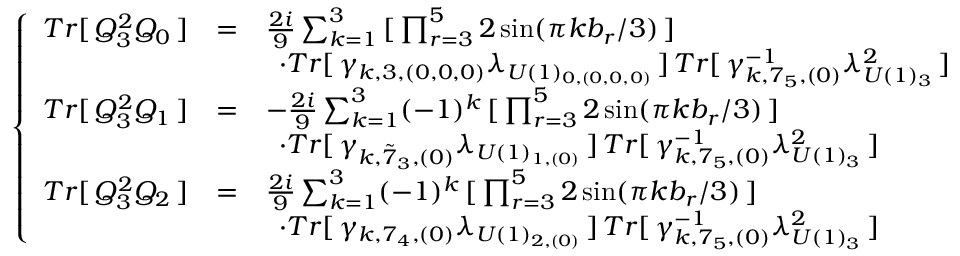Convert formula to latex. <formula><loc_0><loc_0><loc_500><loc_500>\left \{ \begin{array} { l l l } { { T r [ \, Q _ { 3 } ^ { 2 } Q _ { 0 } \, ] } } & { = } & { { \frac { 2 i } { 9 } \sum _ { k = 1 } ^ { 3 } \, [ \, \prod _ { r = 3 } ^ { 5 } 2 \sin ( { \pi k b _ { r } } / { 3 } ) \, ] \, } } & { { \, \cdot T r [ \, \gamma _ { k , 3 , ( 0 , 0 , 0 ) } \lambda _ { U ( 1 ) _ { 0 , ( 0 , 0 , 0 ) } } \, ] \, T r [ \, \gamma _ { k , 7 _ { 5 } , ( 0 ) } ^ { - 1 } \lambda _ { U ( 1 ) _ { 3 } } ^ { 2 } \, ] } } \\ { { T r [ \, Q _ { 3 } ^ { 2 } Q _ { 1 } \, ] } } & { = } & { { - \frac { 2 i } { 9 } \sum _ { k = 1 } ^ { 3 } ( - 1 ) ^ { k } \, [ \, \prod _ { r = 3 } ^ { 5 } 2 \sin ( { \pi k b _ { r } } / { 3 } ) \, ] \, } } & { { \, \cdot T r [ \, \gamma _ { k , { \tilde { 7 } } _ { 3 } , ( 0 ) } \lambda _ { U ( 1 ) _ { 1 , ( 0 ) } } \, ] \, T r [ \, \gamma _ { k , 7 _ { 5 } , ( 0 ) } ^ { - 1 } \lambda _ { U ( 1 ) _ { 3 } } ^ { 2 } \, ] } } \\ { { T r [ \, Q _ { 3 } ^ { 2 } Q _ { 2 } \, ] } } & { = } & { { \frac { 2 i } { 9 } \sum _ { k = 1 } ^ { 3 } ( - 1 ) ^ { k } \, [ \, \prod _ { r = 3 } ^ { 5 } 2 \sin ( { \pi k b _ { r } } / { 3 } ) \, ] \, } } & { { \, \cdot T r [ \, \gamma _ { k , 7 _ { 4 } , ( 0 ) } \lambda _ { U ( 1 ) _ { 2 , ( 0 ) } } \, ] \, T r [ \, \gamma _ { k , 7 _ { 5 } , ( 0 ) } ^ { - 1 } \lambda _ { U ( 1 ) _ { 3 } } ^ { 2 } \, ] } } \end{array}</formula> 